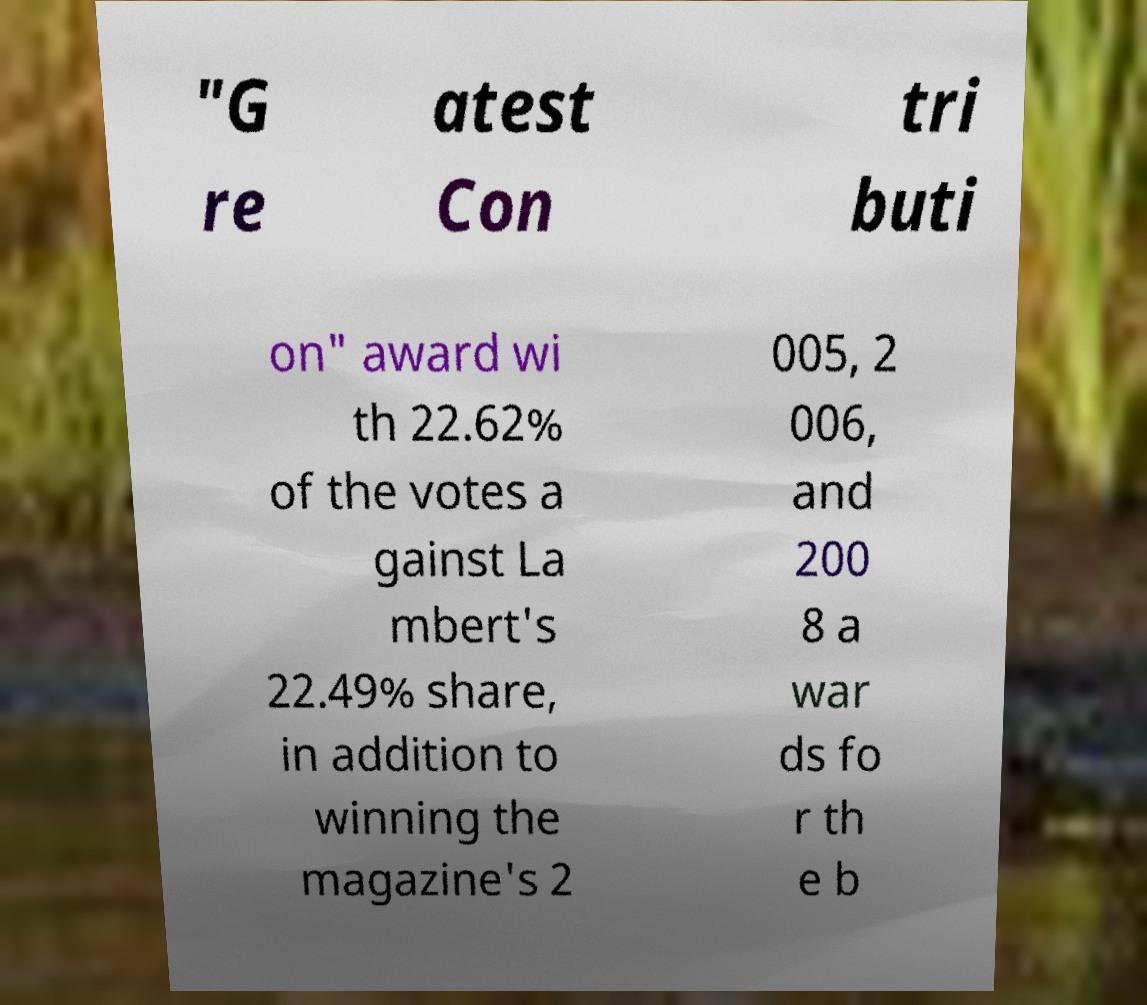Please read and relay the text visible in this image. What does it say? "G re atest Con tri buti on" award wi th 22.62% of the votes a gainst La mbert's 22.49% share, in addition to winning the magazine's 2 005, 2 006, and 200 8 a war ds fo r th e b 